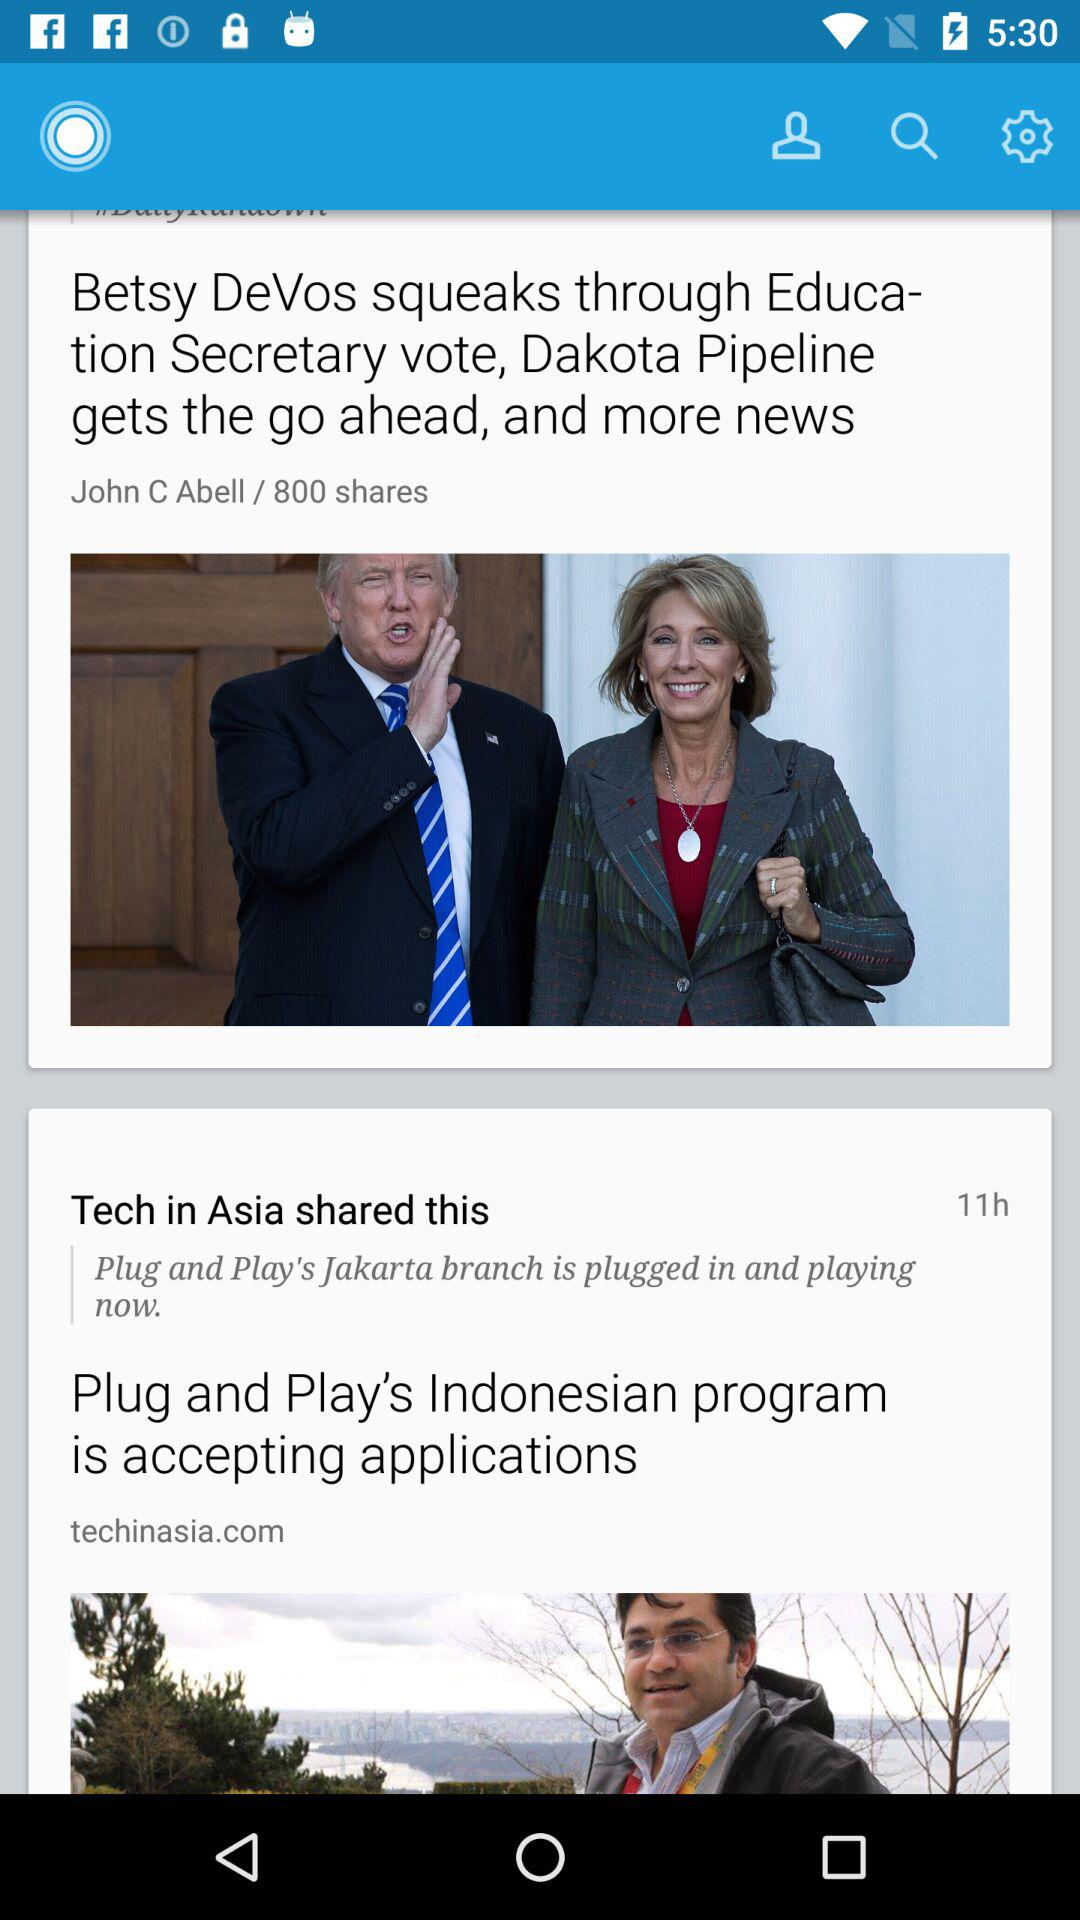How long ago was "Betsy DeVos squeaks through Education Secretary vote, Dakota Pipeline gets the go ahead, and more news" published?
When the provided information is insufficient, respond with <no answer>. <no answer> 